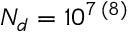<formula> <loc_0><loc_0><loc_500><loc_500>N _ { d } = 1 0 ^ { 7 \, ( 8 ) }</formula> 